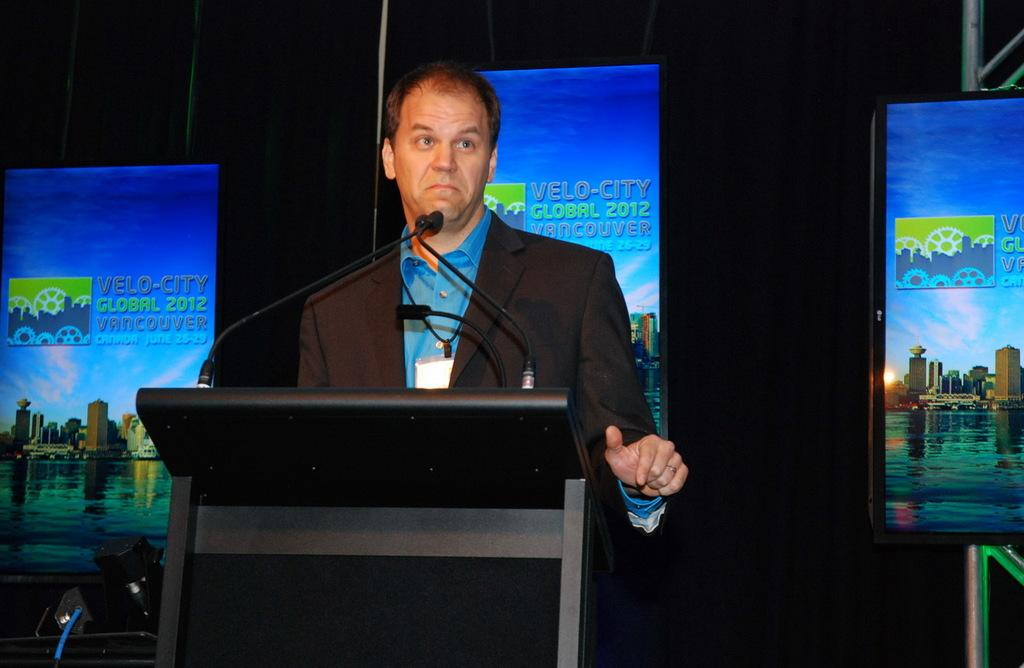<image>
Provide a brief description of the given image. A male presenter standing in front of the Velo City Global 2012 sign 